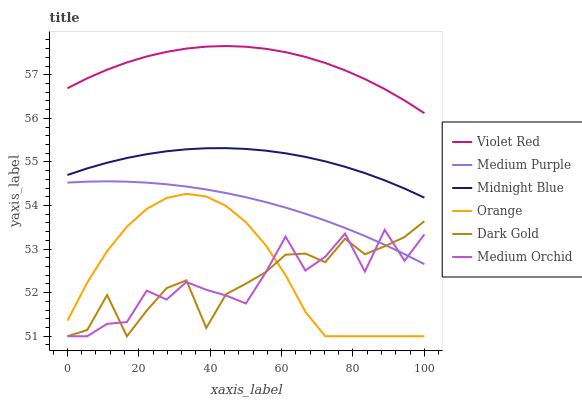Does Medium Orchid have the minimum area under the curve?
Answer yes or no. Yes. Does Violet Red have the maximum area under the curve?
Answer yes or no. Yes. Does Midnight Blue have the minimum area under the curve?
Answer yes or no. No. Does Midnight Blue have the maximum area under the curve?
Answer yes or no. No. Is Medium Purple the smoothest?
Answer yes or no. Yes. Is Medium Orchid the roughest?
Answer yes or no. Yes. Is Midnight Blue the smoothest?
Answer yes or no. No. Is Midnight Blue the roughest?
Answer yes or no. No. Does Dark Gold have the lowest value?
Answer yes or no. Yes. Does Midnight Blue have the lowest value?
Answer yes or no. No. Does Violet Red have the highest value?
Answer yes or no. Yes. Does Midnight Blue have the highest value?
Answer yes or no. No. Is Medium Orchid less than Violet Red?
Answer yes or no. Yes. Is Midnight Blue greater than Medium Orchid?
Answer yes or no. Yes. Does Dark Gold intersect Orange?
Answer yes or no. Yes. Is Dark Gold less than Orange?
Answer yes or no. No. Is Dark Gold greater than Orange?
Answer yes or no. No. Does Medium Orchid intersect Violet Red?
Answer yes or no. No. 